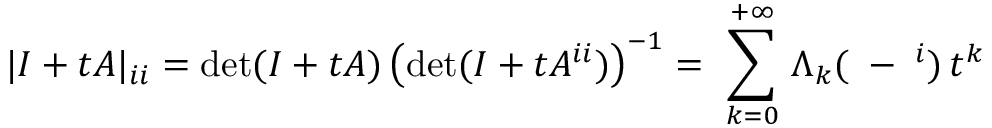<formula> <loc_0><loc_0><loc_500><loc_500>| I + t A | _ { i i } = d e t ( I + t A ) \left ( d e t ( I + t A ^ { i i } ) \right ) ^ { - 1 } = \ \sum _ { k = 0 } ^ { + \infty } \, \Lambda _ { k } ( { \alpha } - { \alpha } ^ { i } ) \, t ^ { k }</formula> 